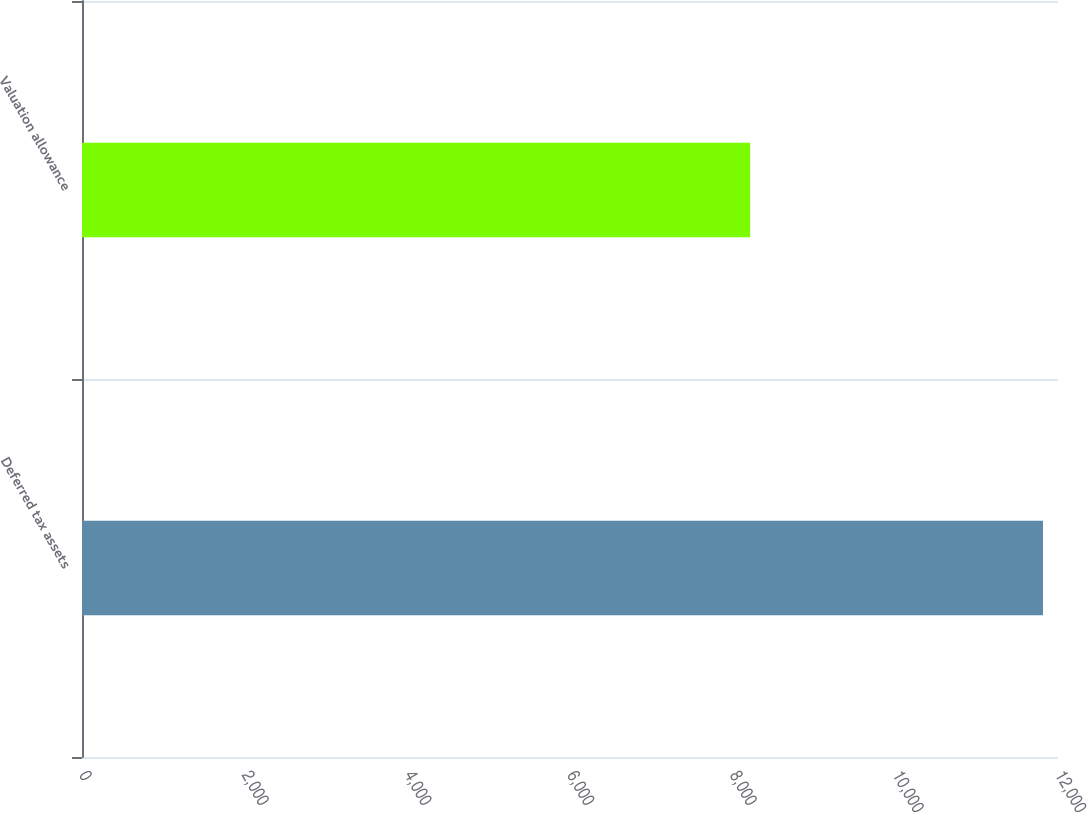Convert chart to OTSL. <chart><loc_0><loc_0><loc_500><loc_500><bar_chart><fcel>Deferred tax assets<fcel>Valuation allowance<nl><fcel>11815<fcel>8215<nl></chart> 